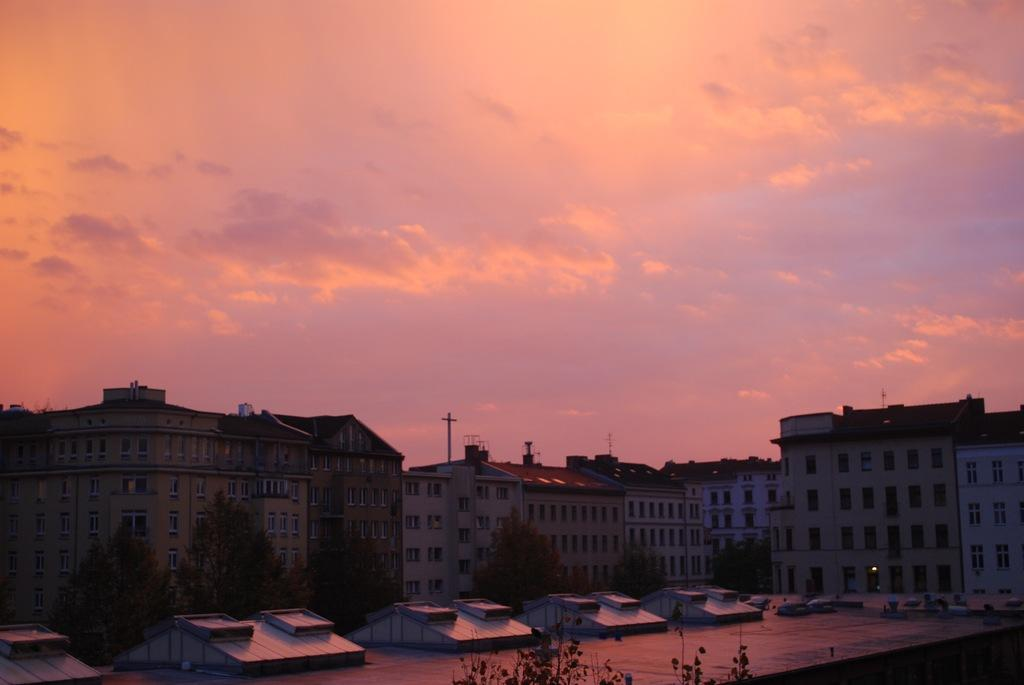Where was the image taken? The image was clicked outside. What can be seen in the middle of the image? There are buildings in the middle of the image. What type of vegetation is at the bottom of the image? There are trees at the bottom of the image. What is visible at the top of the image? The sky is visible at the top of the image. What type of knife is being used to turn the page in the image? There is no knife or page present in the image. What is the yoke used for in the image? There is no yoke present in the image. 